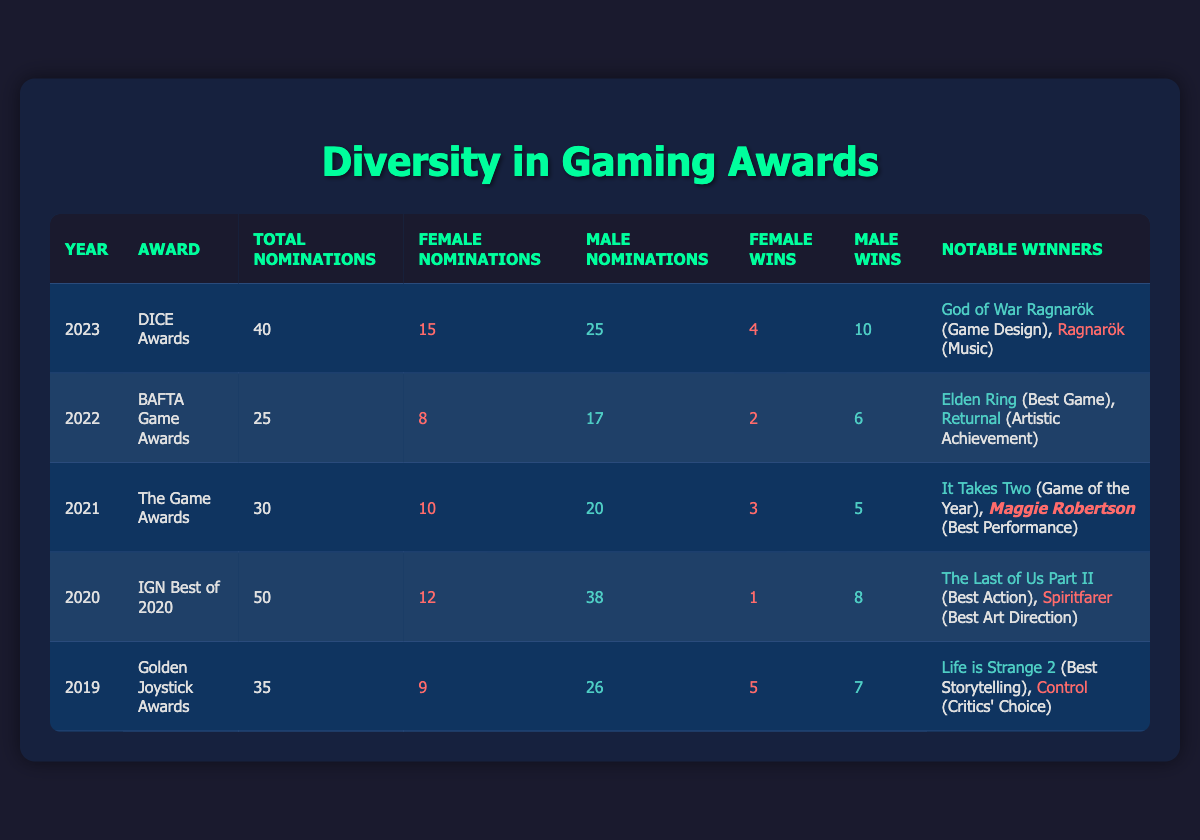What year had the highest total nominations? The highest total nominations is 50, which occurred in 2020 during the IGN Best of 2020 awards.
Answer: 2020 How many female wins were there in 2022? In 2022, the BAFTA Game Awards had 2 wins for female nominees.
Answer: 2 What is the total number of male nominations across all years? Adding the male nominations from all entries gives us: 25 (2023) + 17 (2022) + 20 (2021) + 38 (2020) + 26 (2019) = 126 male nominations.
Answer: 126 Which award had the most nominations for female nominees? The DICE Awards in 2023 had the most female nominations, totaling 15.
Answer: 15 Did any female winner receive an award for the Best Game category? No, based on the data, no female nominee won in the Best Game category in any year listed.
Answer: No What's the total number of nominations across all awards from 2019 to 2023? Adding the totals from each year: 35 (2019) + 50 (2020) + 30 (2021) + 25 (2022) + 40 (2023) = 180 total nominations.
Answer: 180 How many more male wins were there compared to female wins in 2021? In 2021, there were 5 male wins and 3 female wins, so the difference is 5 - 3 = 2 more male wins.
Answer: 2 Which award had the highest ratio of female nominations to total nominations? The ratio for female nominations in 2023 is 15/40 = 0.375. The ratio for 2021 is 10/30 = 0.333. Thus, 2023 has the highest ratio.
Answer: 2023 How many total awards did female nominees win in 2019? In 2019, female nominees won a total of 5 awards, as indicated in the table.
Answer: 5 Was there a year where the number of female nominations exceeded the number of male nominations? Yes, in 2023, there were 15 female nominations, which exceeded the 25 male nominations.
Answer: Yes 